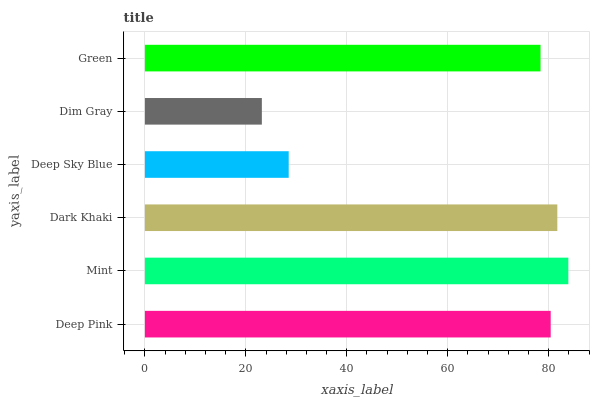Is Dim Gray the minimum?
Answer yes or no. Yes. Is Mint the maximum?
Answer yes or no. Yes. Is Dark Khaki the minimum?
Answer yes or no. No. Is Dark Khaki the maximum?
Answer yes or no. No. Is Mint greater than Dark Khaki?
Answer yes or no. Yes. Is Dark Khaki less than Mint?
Answer yes or no. Yes. Is Dark Khaki greater than Mint?
Answer yes or no. No. Is Mint less than Dark Khaki?
Answer yes or no. No. Is Deep Pink the high median?
Answer yes or no. Yes. Is Green the low median?
Answer yes or no. Yes. Is Dim Gray the high median?
Answer yes or no. No. Is Mint the low median?
Answer yes or no. No. 